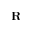<formula> <loc_0><loc_0><loc_500><loc_500>R</formula> 